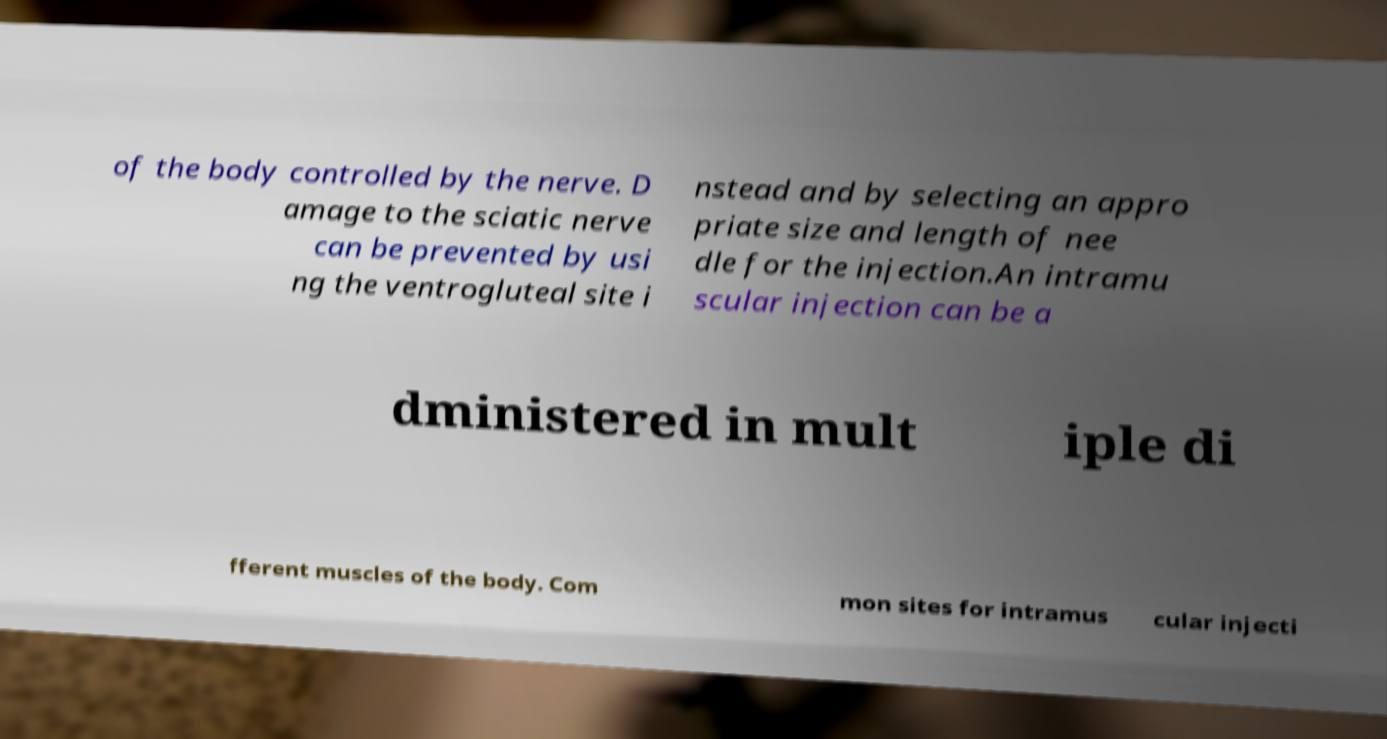What messages or text are displayed in this image? I need them in a readable, typed format. of the body controlled by the nerve. D amage to the sciatic nerve can be prevented by usi ng the ventrogluteal site i nstead and by selecting an appro priate size and length of nee dle for the injection.An intramu scular injection can be a dministered in mult iple di fferent muscles of the body. Com mon sites for intramus cular injecti 